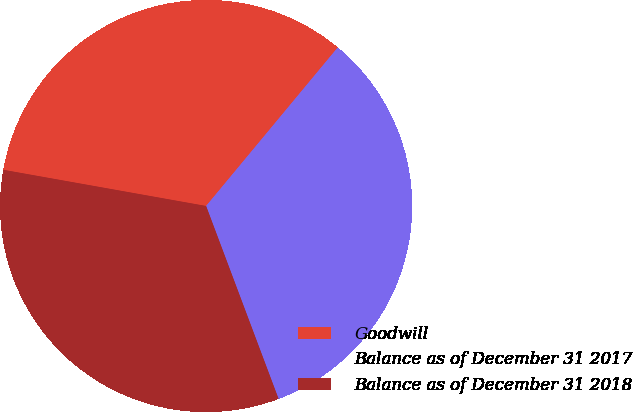<chart> <loc_0><loc_0><loc_500><loc_500><pie_chart><fcel>Goodwill<fcel>Balance as of December 31 2017<fcel>Balance as of December 31 2018<nl><fcel>33.22%<fcel>33.25%<fcel>33.53%<nl></chart> 